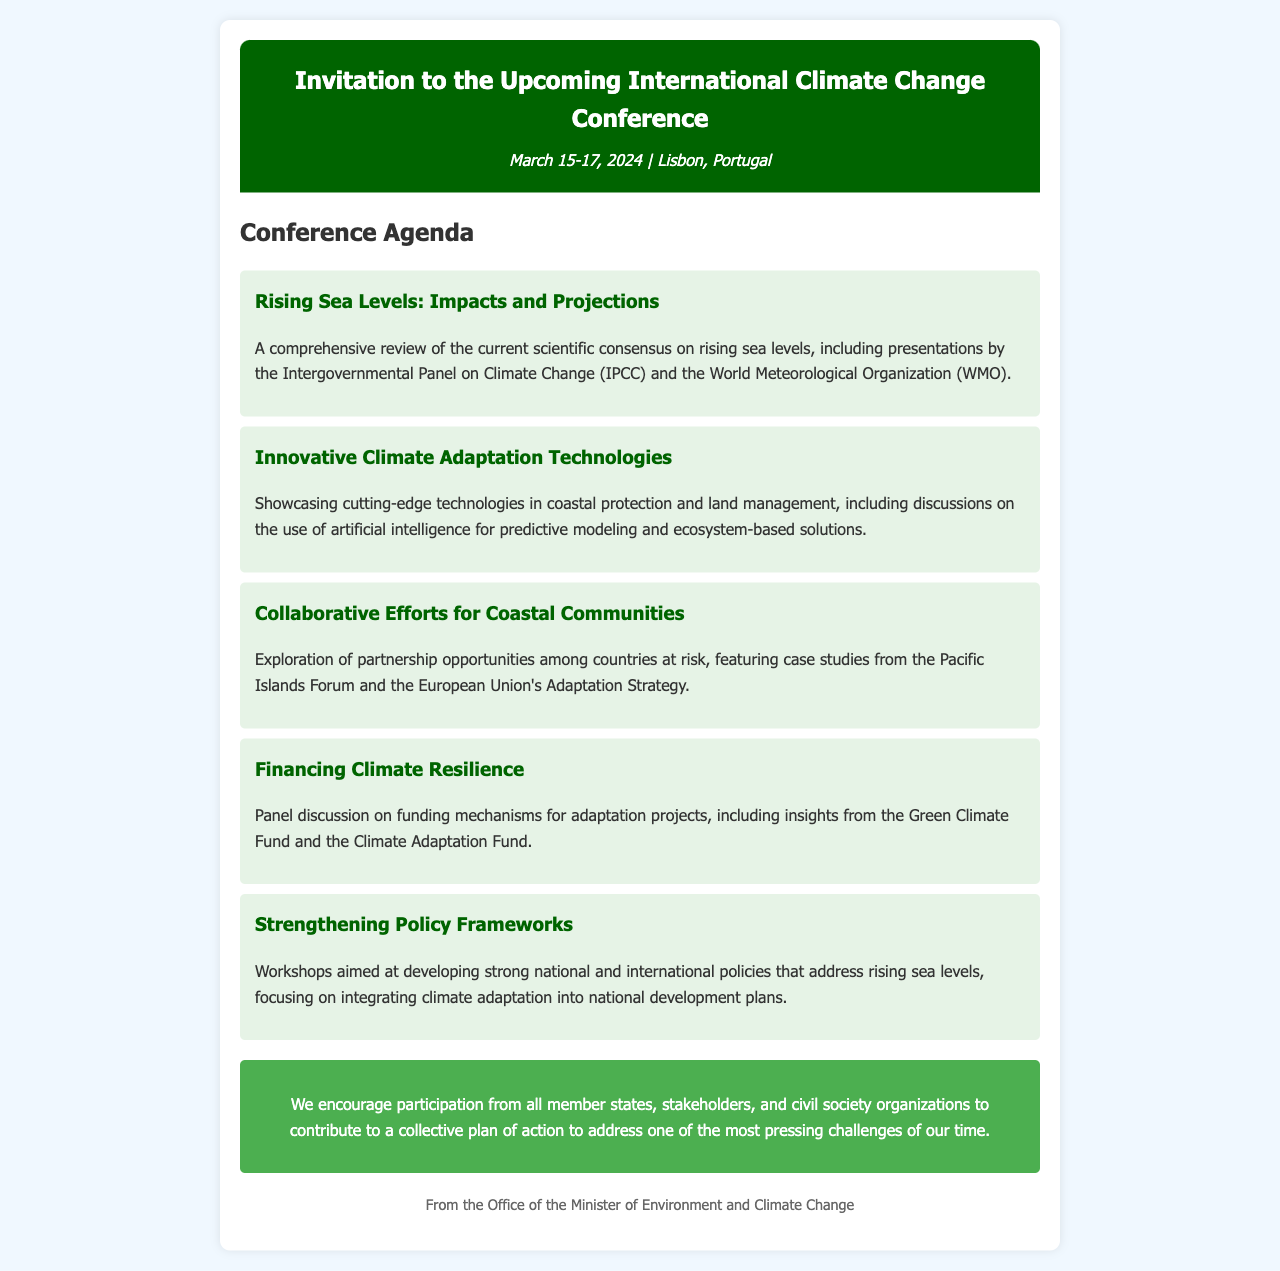What are the dates of the conference? The document specifies that the conference will be held on March 15-17, 2024.
Answer: March 15-17, 2024 Where is the conference taking place? The letter states that the location of the conference is Lisbon, Portugal.
Answer: Lisbon, Portugal Which organization will present on rising sea levels? The agenda mentions presentations by the Intergovernmental Panel on Climate Change (IPCC) regarding rising sea levels.
Answer: Intergovernmental Panel on Climate Change (IPCC) What innovative focus area will be showcased at the conference? The agenda includes a session dedicated to showcasing cutting-edge technologies in coastal protection and land management.
Answer: Innovative Climate Adaptation Technologies What is being explored in the session about coastal communities? The agenda indicates that the session will explore partnership opportunities among countries at risk, highlighting collective efforts.
Answer: Partnership opportunities among countries at risk Which funding mechanism is mentioned in relation to financing resilience? The agenda includes insights from the Green Climate Fund during the discussion on financing climate resilience.
Answer: Green Climate Fund What will the workshops focus on according to the agenda? The workshops are aimed at developing strong national and international policies addressing rising sea levels.
Answer: Strong national and international policies What does the call-to-action encourage? The call-to-action encourages participation from all member states, stakeholders, and civil society organizations.
Answer: Participation from all member states, stakeholders, and civil society organizations 